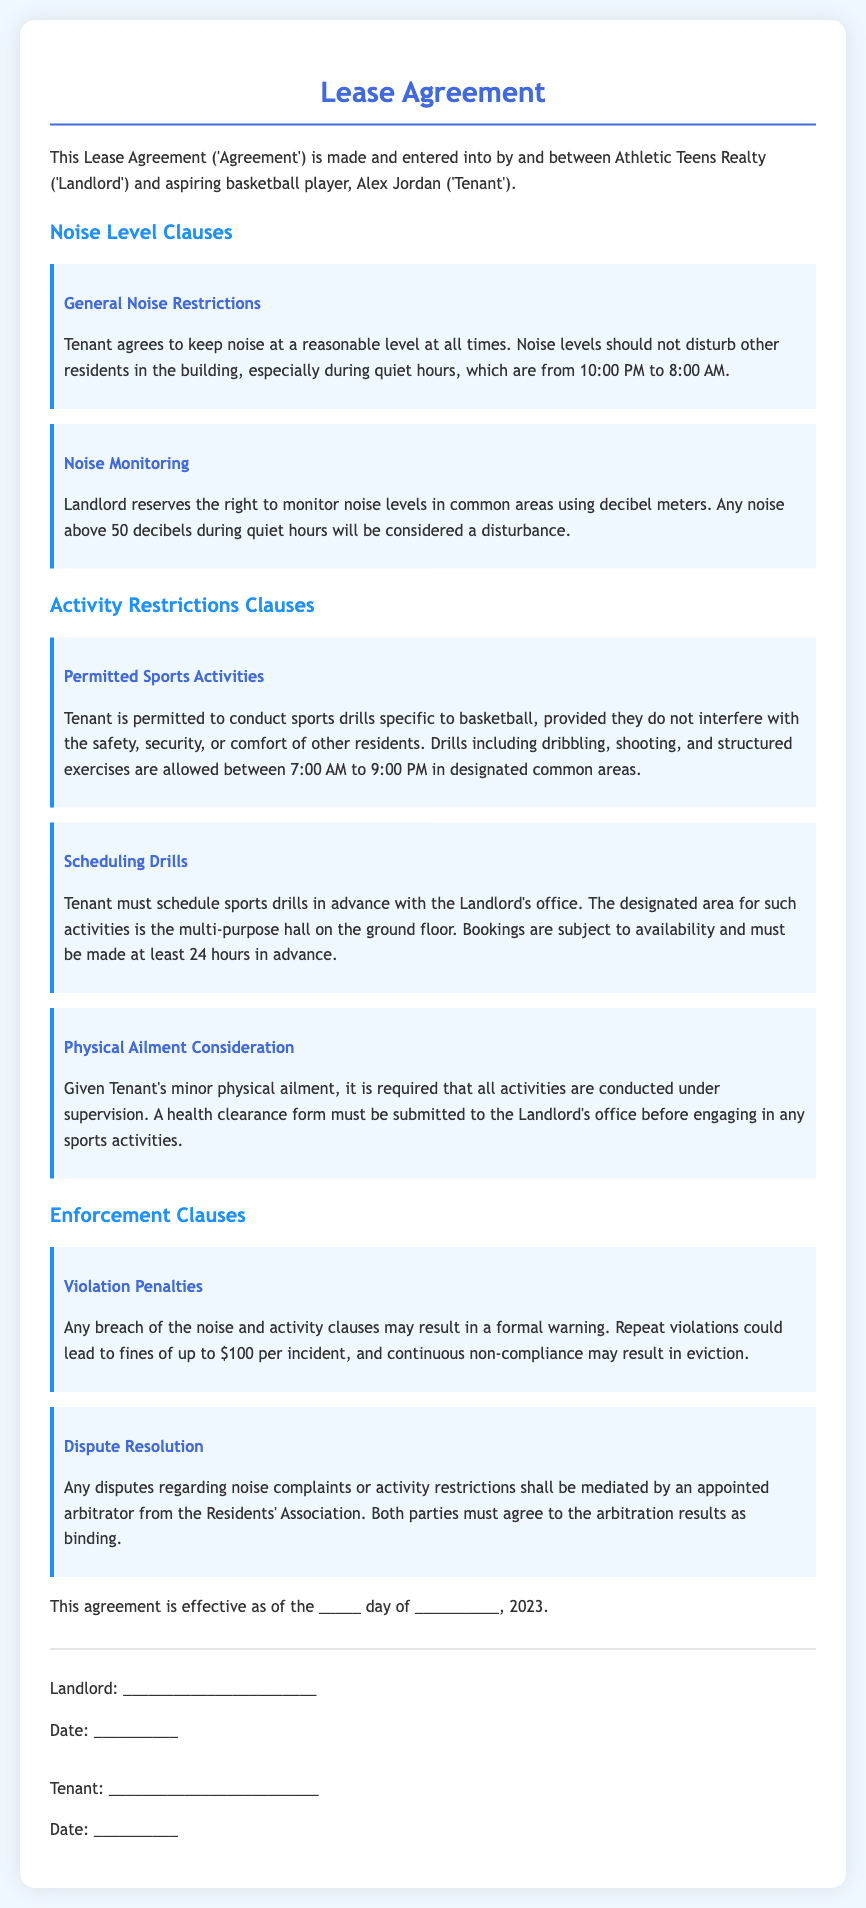What are the quiet hours? The quiet hours are specifically mentioned in the noise restrictions clause as the times during which noise should be minimized, which are from 10:00 PM to 8:00 AM.
Answer: 10:00 PM to 8:00 AM What is the maximum noise level during quiet hours? The noise level restriction is specified in the document, stating that any noise above 50 decibels during these hours will be considered a disturbance.
Answer: 50 decibels What activities are allowed in common areas? The permitted activities for the Tenant are outlined in the activity restrictions, specifically mentioning that dribbling, shooting, and structured exercises are allowed.
Answer: Dribbling, shooting, and structured exercises What is required before engaging in sports activities? The document states that a health clearance form must be submitted to the Landlord's office prior to participating in any sports activities due to the Tenant's physical ailment.
Answer: Health clearance form How far in advance must drills be scheduled? The scheduling clause indicates that bookings for sports drills must be made at least 24 hours in advance.
Answer: 24 hours What is the penalty for repeat violations of the noise clauses? The violation penalties outlined indicate that repeat offenses could lead to a fine, which is specified as a certain amount per incident.
Answer: $100 per incident Where must Tenant conduct scheduled sports drills? The scheduling clause specifies that the designated area for sports drills is the multi-purpose hall on the ground floor.
Answer: Multi-purpose hall Who mediates disputes regarding noise complaints? The dispute resolution clause states that any disputes shall be mediated by an appointed arbitrator from the Residents' Association.
Answer: Appointed arbitrator from the Residents' Association 